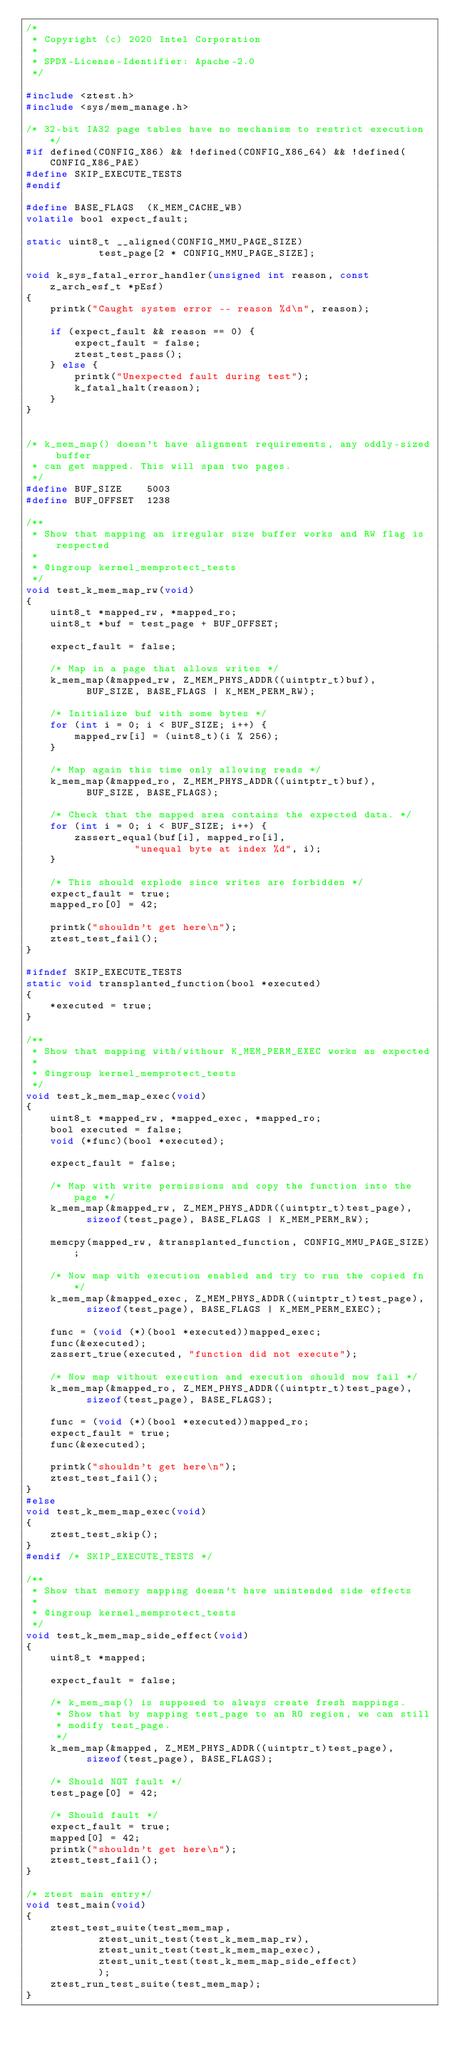<code> <loc_0><loc_0><loc_500><loc_500><_C_>/*
 * Copyright (c) 2020 Intel Corporation
 *
 * SPDX-License-Identifier: Apache-2.0
 */

#include <ztest.h>
#include <sys/mem_manage.h>

/* 32-bit IA32 page tables have no mechanism to restrict execution */
#if defined(CONFIG_X86) && !defined(CONFIG_X86_64) && !defined(CONFIG_X86_PAE)
#define SKIP_EXECUTE_TESTS
#endif

#define BASE_FLAGS	(K_MEM_CACHE_WB)
volatile bool expect_fault;

static uint8_t __aligned(CONFIG_MMU_PAGE_SIZE)
			test_page[2 * CONFIG_MMU_PAGE_SIZE];

void k_sys_fatal_error_handler(unsigned int reason, const z_arch_esf_t *pEsf)
{
	printk("Caught system error -- reason %d\n", reason);

	if (expect_fault && reason == 0) {
		expect_fault = false;
		ztest_test_pass();
	} else {
		printk("Unexpected fault during test");
		k_fatal_halt(reason);
	}
}


/* k_mem_map() doesn't have alignment requirements, any oddly-sized buffer
 * can get mapped. This will span two pages.
 */
#define BUF_SIZE	5003
#define BUF_OFFSET	1238

/**
 * Show that mapping an irregular size buffer works and RW flag is respected
 *
 * @ingroup kernel_memprotect_tests
 */
void test_k_mem_map_rw(void)
{
	uint8_t *mapped_rw, *mapped_ro;
	uint8_t *buf = test_page + BUF_OFFSET;

	expect_fault = false;

	/* Map in a page that allows writes */
	k_mem_map(&mapped_rw, Z_MEM_PHYS_ADDR((uintptr_t)buf),
		  BUF_SIZE, BASE_FLAGS | K_MEM_PERM_RW);

	/* Initialize buf with some bytes */
	for (int i = 0; i < BUF_SIZE; i++) {
		mapped_rw[i] = (uint8_t)(i % 256);
	}

	/* Map again this time only allowing reads */
	k_mem_map(&mapped_ro, Z_MEM_PHYS_ADDR((uintptr_t)buf),
		  BUF_SIZE, BASE_FLAGS);

	/* Check that the mapped area contains the expected data. */
	for (int i = 0; i < BUF_SIZE; i++) {
		zassert_equal(buf[i], mapped_ro[i],
			      "unequal byte at index %d", i);
	}

	/* This should explode since writes are forbidden */
	expect_fault = true;
	mapped_ro[0] = 42;

	printk("shouldn't get here\n");
	ztest_test_fail();
}

#ifndef SKIP_EXECUTE_TESTS
static void transplanted_function(bool *executed)
{
	*executed = true;
}

/**
 * Show that mapping with/withour K_MEM_PERM_EXEC works as expected
 *
 * @ingroup kernel_memprotect_tests
 */
void test_k_mem_map_exec(void)
{
	uint8_t *mapped_rw, *mapped_exec, *mapped_ro;
	bool executed = false;
	void (*func)(bool *executed);

	expect_fault = false;

	/* Map with write permissions and copy the function into the page */
	k_mem_map(&mapped_rw, Z_MEM_PHYS_ADDR((uintptr_t)test_page),
		  sizeof(test_page), BASE_FLAGS | K_MEM_PERM_RW);

	memcpy(mapped_rw, &transplanted_function, CONFIG_MMU_PAGE_SIZE);

	/* Now map with execution enabled and try to run the copied fn */
	k_mem_map(&mapped_exec, Z_MEM_PHYS_ADDR((uintptr_t)test_page),
		  sizeof(test_page), BASE_FLAGS | K_MEM_PERM_EXEC);

	func = (void (*)(bool *executed))mapped_exec;
	func(&executed);
	zassert_true(executed, "function did not execute");

	/* Now map without execution and execution should now fail */
	k_mem_map(&mapped_ro, Z_MEM_PHYS_ADDR((uintptr_t)test_page),
		  sizeof(test_page), BASE_FLAGS);

	func = (void (*)(bool *executed))mapped_ro;
	expect_fault = true;
	func(&executed);

	printk("shouldn't get here\n");
	ztest_test_fail();
}
#else
void test_k_mem_map_exec(void)
{
	ztest_test_skip();
}
#endif /* SKIP_EXECUTE_TESTS */

/**
 * Show that memory mapping doesn't have unintended side effects
 *
 * @ingroup kernel_memprotect_tests
 */
void test_k_mem_map_side_effect(void)
{
	uint8_t *mapped;

	expect_fault = false;

	/* k_mem_map() is supposed to always create fresh mappings.
	 * Show that by mapping test_page to an RO region, we can still
	 * modify test_page.
	 */
	k_mem_map(&mapped, Z_MEM_PHYS_ADDR((uintptr_t)test_page),
		  sizeof(test_page), BASE_FLAGS);

	/* Should NOT fault */
	test_page[0] = 42;

	/* Should fault */
	expect_fault = true;
	mapped[0] = 42;
	printk("shouldn't get here\n");
	ztest_test_fail();
}

/* ztest main entry*/
void test_main(void)
{
	ztest_test_suite(test_mem_map,
			ztest_unit_test(test_k_mem_map_rw),
			ztest_unit_test(test_k_mem_map_exec),
			ztest_unit_test(test_k_mem_map_side_effect)
			);
	ztest_run_test_suite(test_mem_map);
}
</code> 